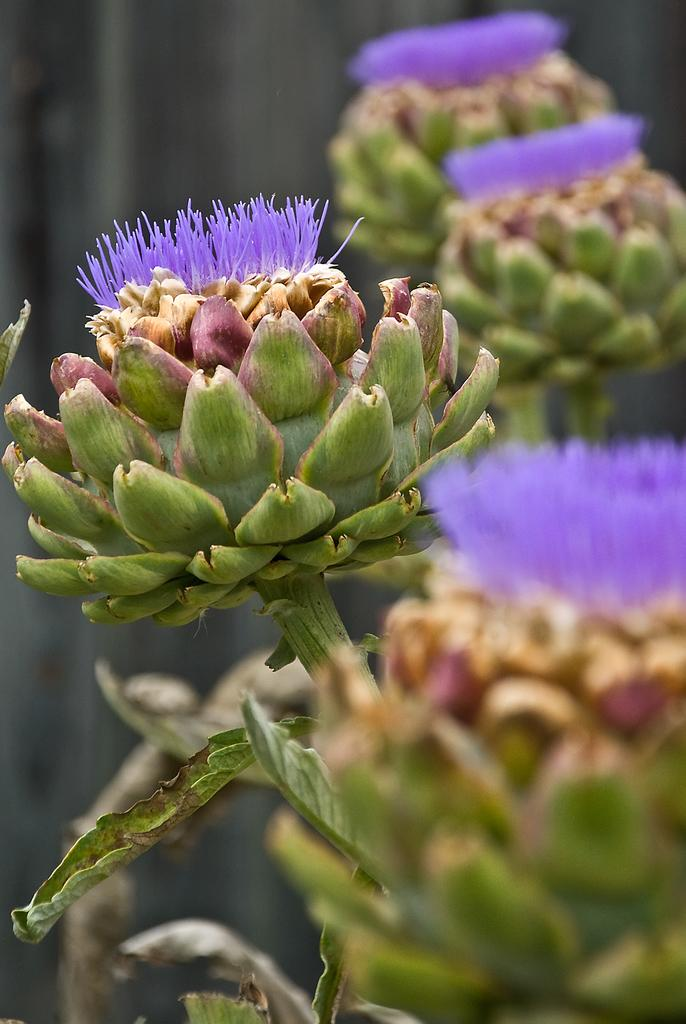What is present in the picture? There is a plant in the picture. What can be observed about the plant's flower? The plant has a violet color flower. How would you describe the background of the image? The background of the image is blurred. What type of magic is being performed on the plant in the image? There is no magic being performed on the plant in the image; it is a natural plant with a violet flower. How much dust can be seen on the plant in the image? There is no dust visible on the plant in the image. 